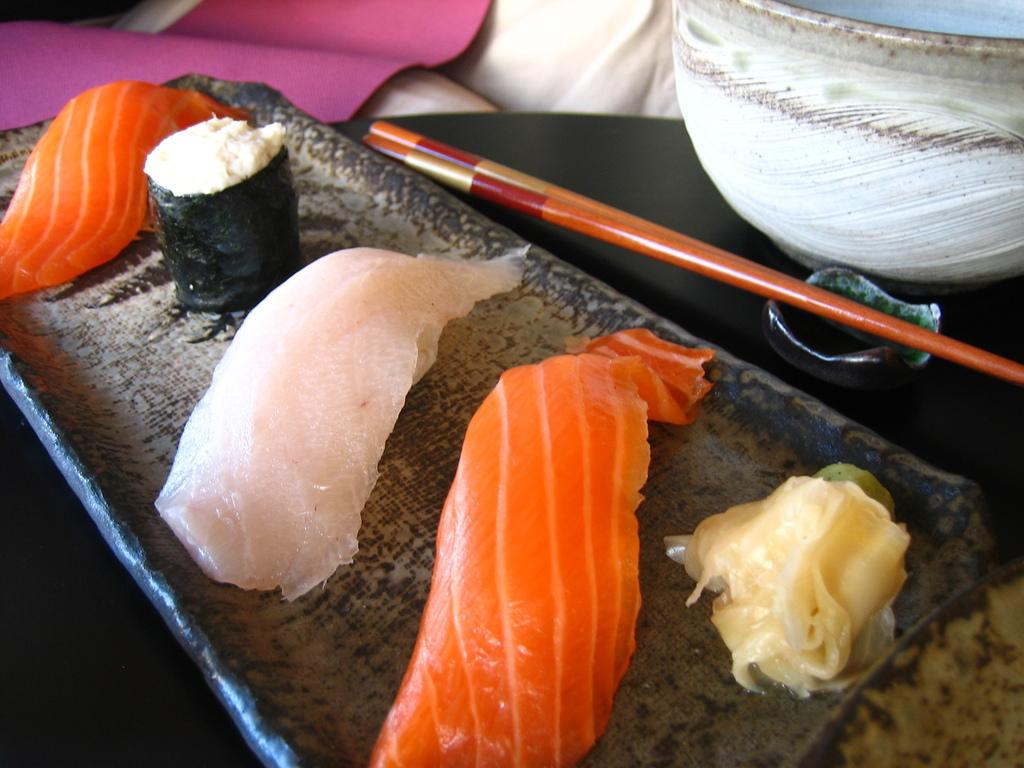What object is present in the image that can hold multiple items? There is a tray in the image that can hold multiple items. What types of creams are on the tray? The tray contains three different types of creams. What natural element can be seen in the image? There is a tree in the image. What container is present in the image? There is a bowl in the image. What long, thin object is visible in the image? There is a stick in the image. How many cattle are grazing near the tree in the image? There are no cattle present in the image; it only features a tree, a tray, creams, a bowl, and a stick. 